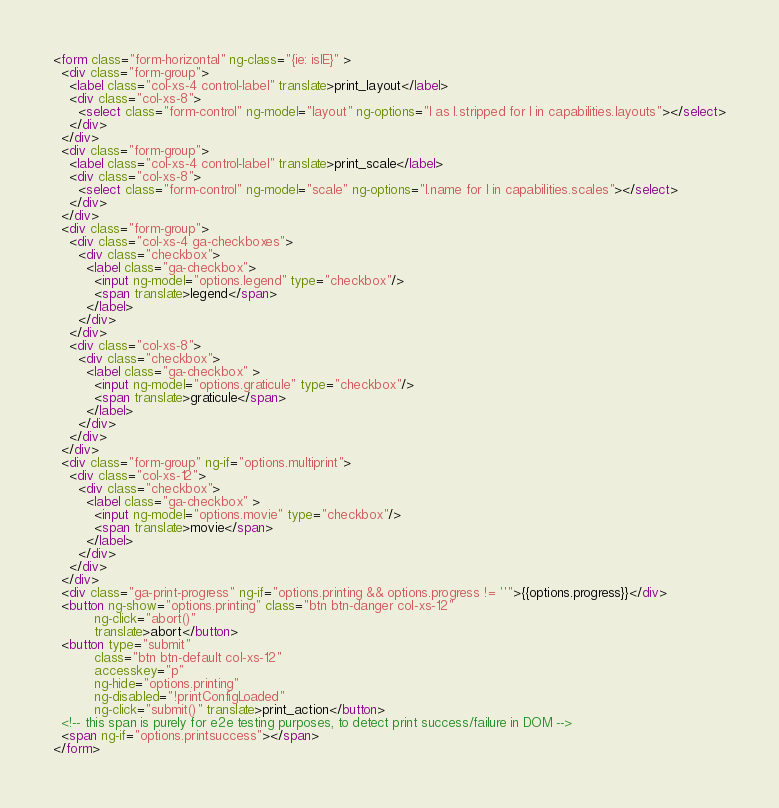Convert code to text. <code><loc_0><loc_0><loc_500><loc_500><_HTML_><form class="form-horizontal" ng-class="{ie: isIE}" >
  <div class="form-group">
    <label class="col-xs-4 control-label" translate>print_layout</label>
    <div class="col-xs-8">
      <select class="form-control" ng-model="layout" ng-options="l as l.stripped for l in capabilities.layouts"></select>
    </div>
  </div>
  <div class="form-group">
    <label class="col-xs-4 control-label" translate>print_scale</label>
    <div class="col-xs-8">
      <select class="form-control" ng-model="scale" ng-options="l.name for l in capabilities.scales"></select>
    </div>
  </div>
  <div class="form-group">
    <div class="col-xs-4 ga-checkboxes">
      <div class="checkbox">
        <label class="ga-checkbox">
          <input ng-model="options.legend" type="checkbox"/>
          <span translate>legend</span>
        </label>
      </div>
    </div>
    <div class="col-xs-8">
      <div class="checkbox">
        <label class="ga-checkbox" >
          <input ng-model="options.graticule" type="checkbox"/>
          <span translate>graticule</span>
        </label>
      </div>
    </div>
  </div>
  <div class="form-group" ng-if="options.multiprint">
    <div class="col-xs-12">
      <div class="checkbox">
        <label class="ga-checkbox" >
          <input ng-model="options.movie" type="checkbox"/>
          <span translate>movie</span>
        </label>
      </div>
    </div>
  </div>
  <div class="ga-print-progress" ng-if="options.printing && options.progress != ''">{{options.progress}}</div>
  <button ng-show="options.printing" class="btn btn-danger col-xs-12" 
          ng-click="abort()" 
          translate>abort</button>
  <button type="submit"
          class="btn btn-default col-xs-12"
          accesskey="p"
          ng-hide="options.printing"
          ng-disabled="!printConfigLoaded"
          ng-click="submit()" translate>print_action</button>
  <!-- this span is purely for e2e testing purposes, to detect print success/failure in DOM -->
  <span ng-if="options.printsuccess"></span>
</form>
</code> 